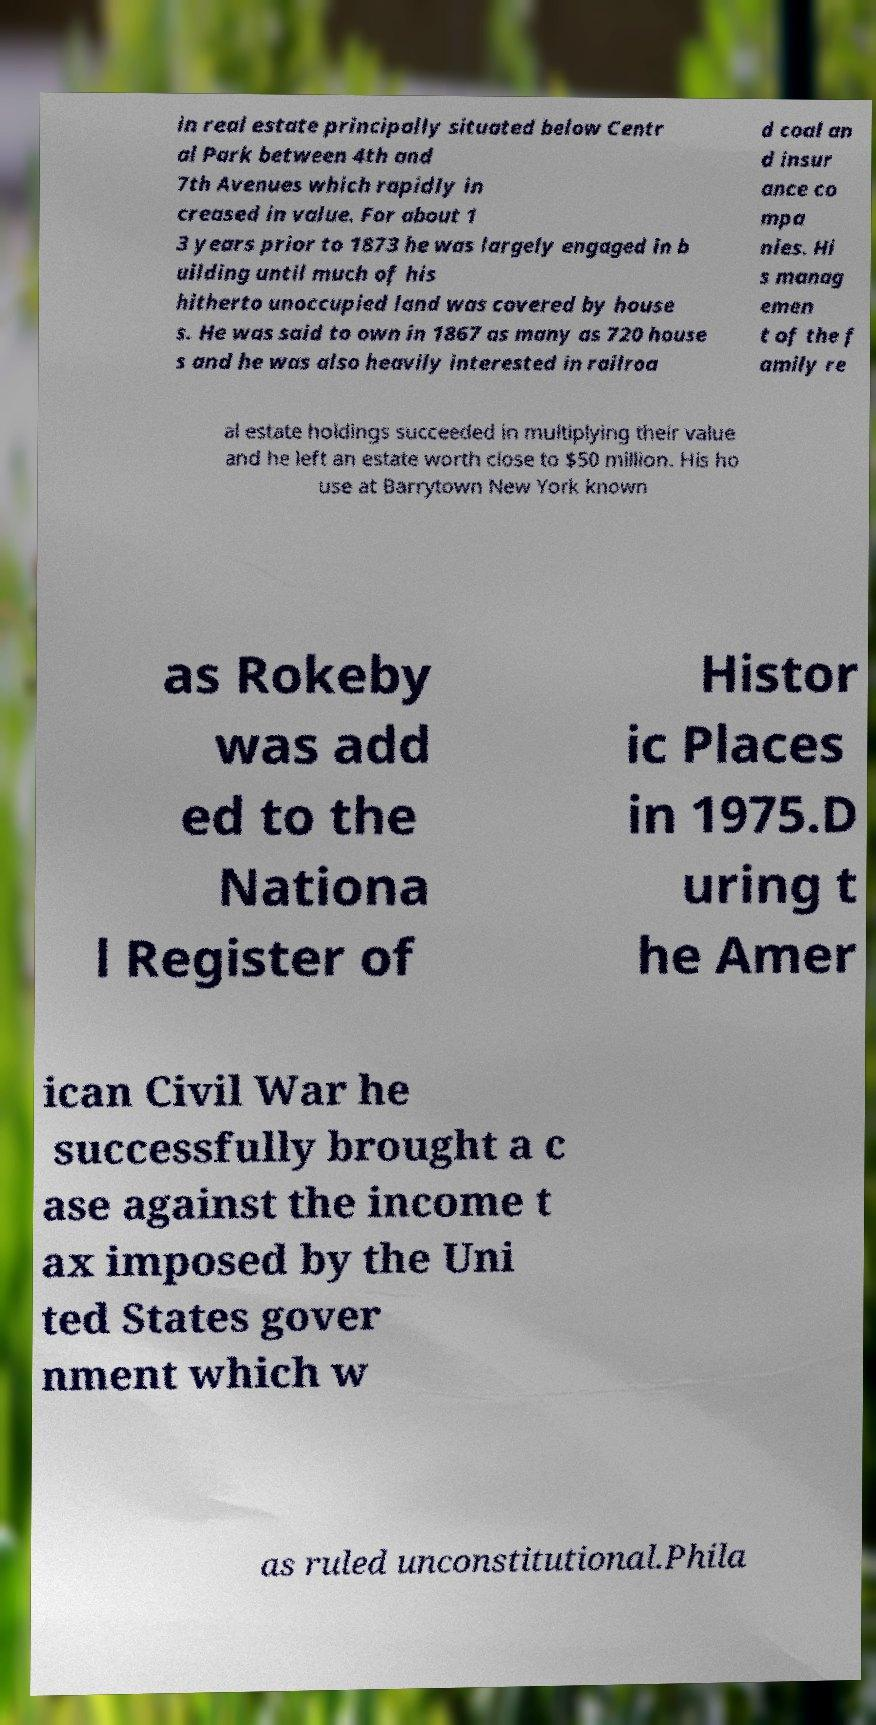There's text embedded in this image that I need extracted. Can you transcribe it verbatim? in real estate principally situated below Centr al Park between 4th and 7th Avenues which rapidly in creased in value. For about 1 3 years prior to 1873 he was largely engaged in b uilding until much of his hitherto unoccupied land was covered by house s. He was said to own in 1867 as many as 720 house s and he was also heavily interested in railroa d coal an d insur ance co mpa nies. Hi s manag emen t of the f amily re al estate holdings succeeded in multiplying their value and he left an estate worth close to $50 million. His ho use at Barrytown New York known as Rokeby was add ed to the Nationa l Register of Histor ic Places in 1975.D uring t he Amer ican Civil War he successfully brought a c ase against the income t ax imposed by the Uni ted States gover nment which w as ruled unconstitutional.Phila 